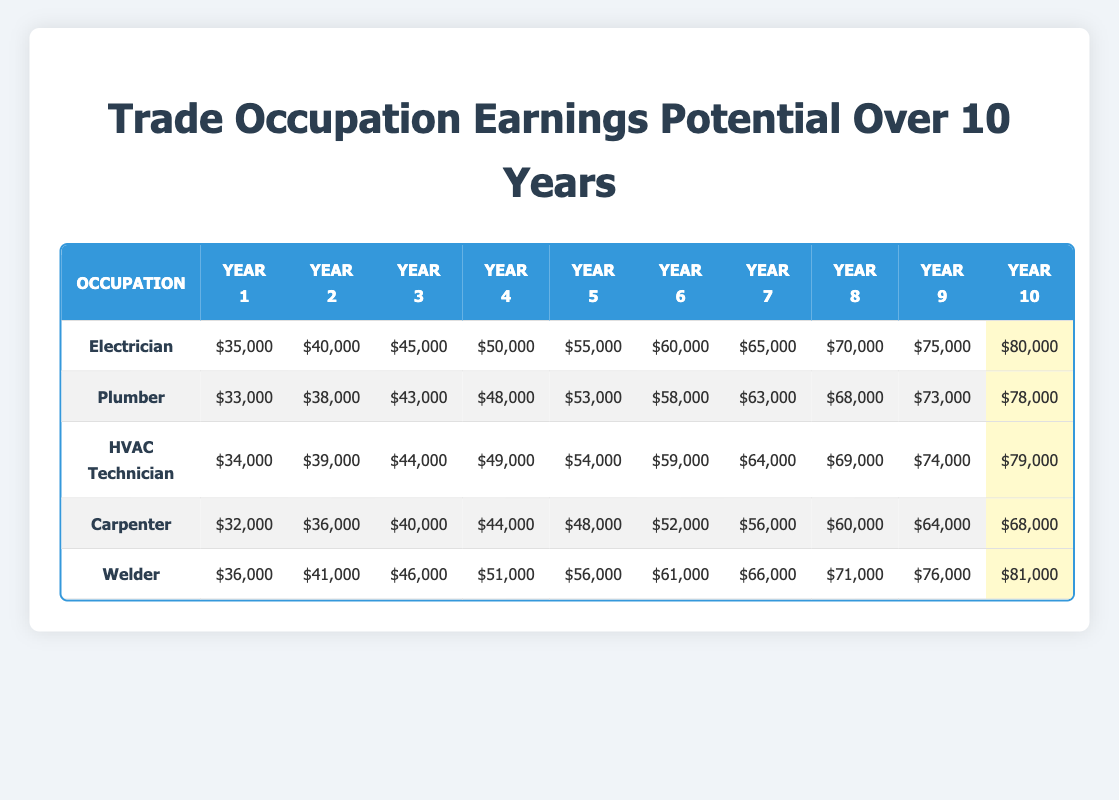What is the annual earning of an electrician in year 5? The table shows that the annual earnings for an electrician in year 5 is $55,000.
Answer: $55,000 Which occupation has the highest earning potential in year 10? By examining the table, we see that in year 10, the electrician earns $80,000, the welder earns $81,000, the plumber earns $78,000, the HVAC technician earns $79,000, and the carpenter earns $68,000. The highest earning is by the welder.
Answer: Welder What is the difference in annual earnings between a plumber in year 1 and year 10? The annual earnings for a plumber in year 1 is $33,000, and in year 10 is $78,000. The difference is $78,000 - $33,000 = $45,000.
Answer: $45,000 Is the earning of an HVAC technician greater than a carpenter in year 6? The earnings for the HVAC technician in year 6 is $59,000, while the carpenter earns $52,000 in the same year. Since $59,000 is greater than $52,000, the statement is true.
Answer: Yes What is the average annual earning for a welder over the 10-year period? First, we sum the annual earnings for a welder: (36,000 + 41,000 + 46,000 + 51,000 + 56,000 + 61,000 + 66,000 + 71,000 + 76,000 + 81,000) =  54,0000. Then, we divide this total by 10 years:  $610,000 / 10 = $61,000.
Answer: $61,000 Which trade occupation saw the greatest percentage increase from year 1 to year 10? For electricians, the increase is from $35,000 to $80,000, which is an increase of $45,000. For plumbers, the increase from $33,000 to $78,000 is $45,000. HVAC technicians increase from $34,000 to $79,000 ($45,000), carpenters from $32,000 to $68,000 ($36,000), and welders from $36,000 to $81,000 ($45,000). After finding the earnings increase for each, we calculate the percentage increase by taking the increase divided by the original earning for each occupation. The calculations show that the percentage increase is highest for electricians (128.57%).
Answer: Electrician In which year does a plumber first earn more than an HVAC technician? In comparing the yearly earnings for each occupation, plumbers earn $33,000 in year 1 and begin to surpass HVAC technicians' earnings from year 6. In year 6, plumbers earn $58,000, while HVAC technicians earn $59,000. This means plumbers surpass HVAC technicians' earnings starting from year 7 when plumbers earn $63,000, and HVAC technicians earn $64,000.
Answer: Year 7 